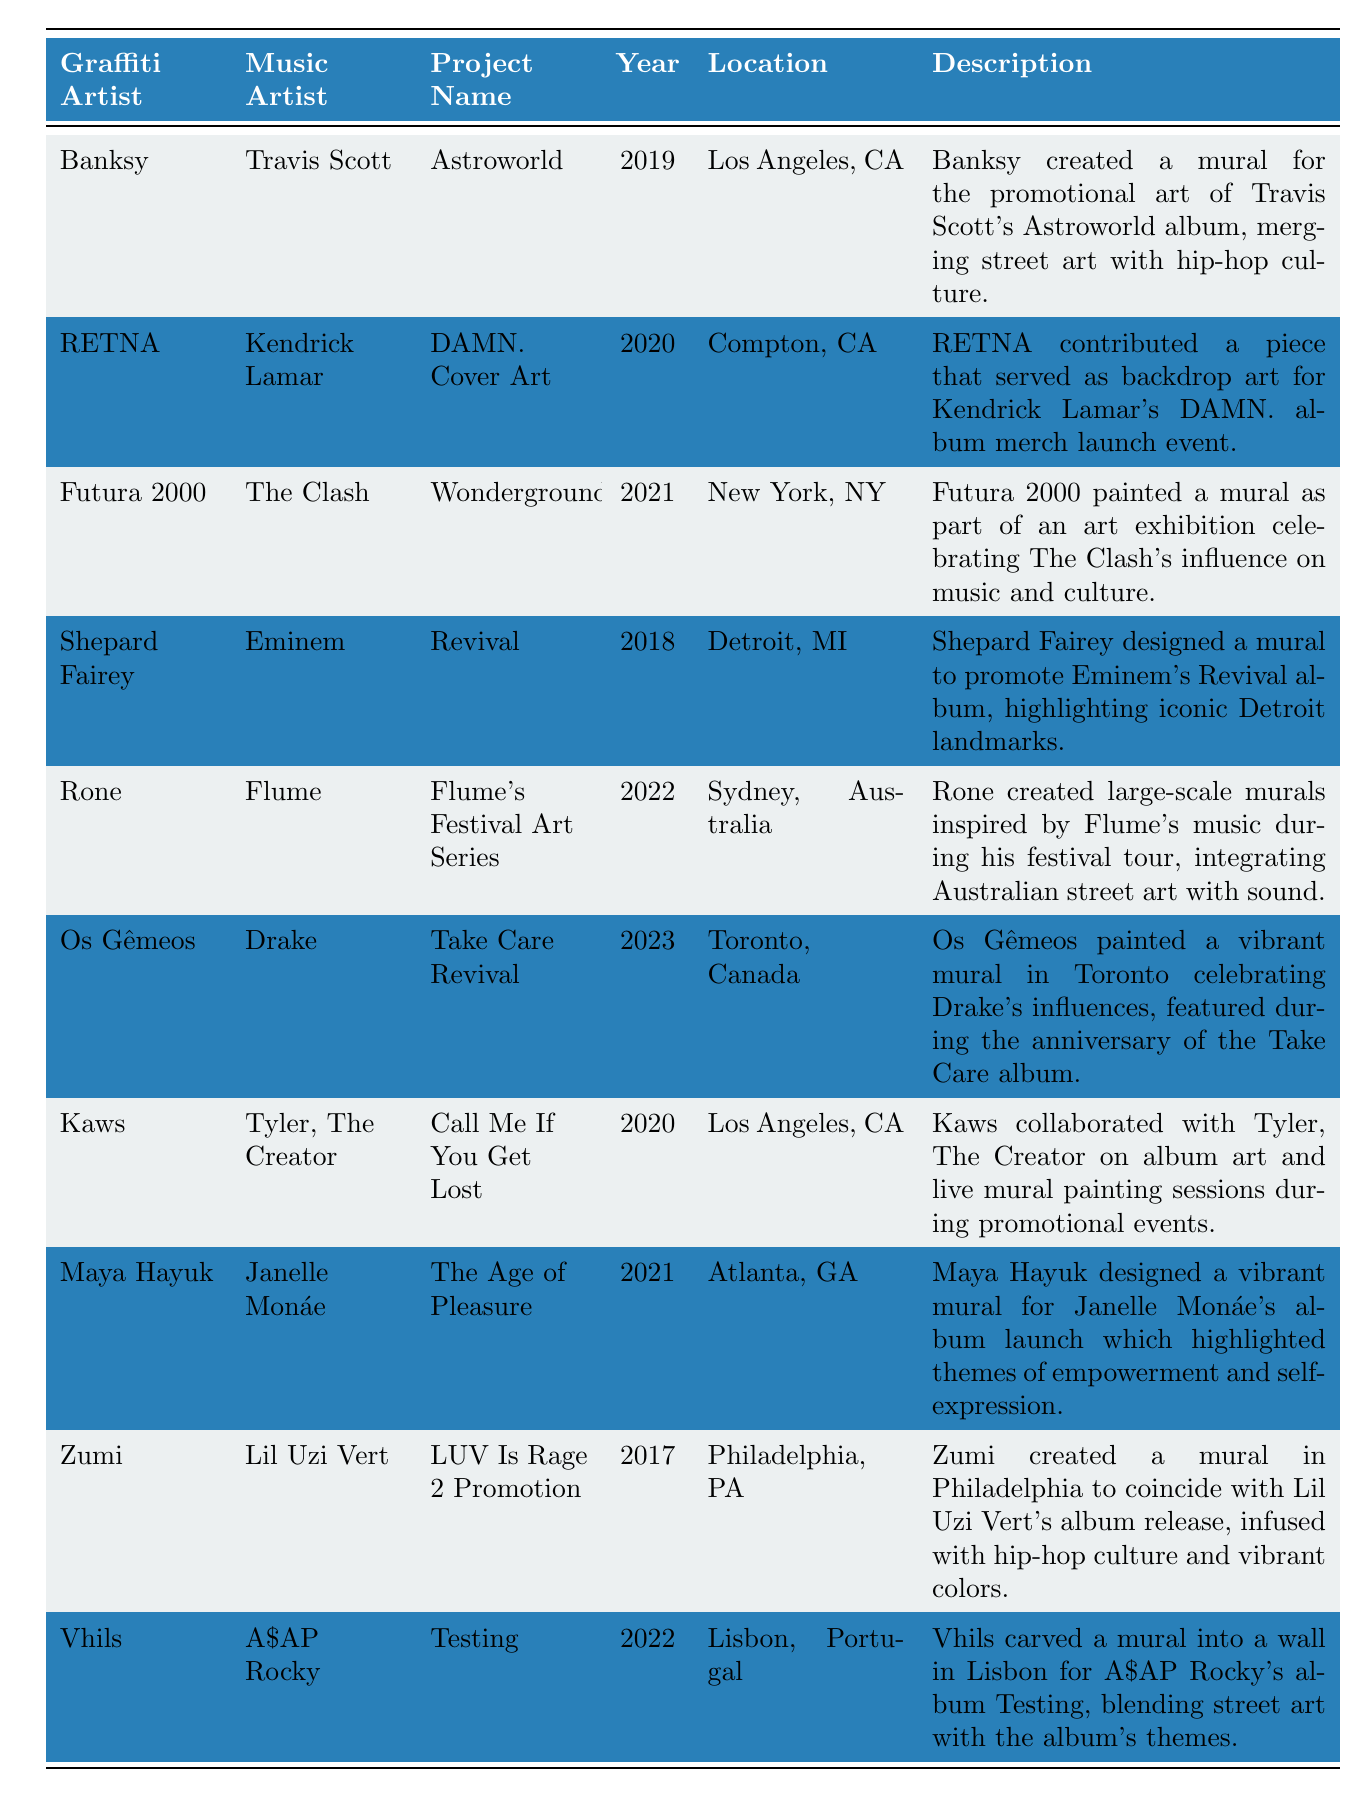What year did Banksy collaborate with Travis Scott? The table shows that Banksy collaborated with Travis Scott in the year 2019.
Answer: 2019 Which music artist collaborated with Shepard Fairey? According to the table, Shepard Fairey collaborated with Eminem.
Answer: Eminem How many graffiti artists collaborated with artists in 2020? The table lists three entries for collaborations in 2020: RETNA with Kendrick Lamar, Kaws with Tyler, The Creator, and Os Gêmeos with Drake. Therefore, the answer is 3.
Answer: 3 Which project name was associated with Lil Uzi Vert? The table specifies that Zumi created a mural for the project "LUV Is Rage 2 Promotion" in conjunction with Lil Uzi Vert.
Answer: LUV Is Rage 2 Promotion What city hosted the collaboration between Rone and Flume? The table indicates that the collaboration between Rone and Flume took place in Sydney, Australia.
Answer: Sydney, Australia Did any artists collaborate in 2018? Yes, the table shows that Shepard Fairey collaborated with Eminem in 2018.
Answer: Yes What is the project name for the collaboration between Os Gêmeos and Drake? From the table, the project name for Os Gêmeos' collaboration with Drake is "Take Care Revival".
Answer: Take Care Revival Who were the graffiti artists involved in murals in Los Angeles? The table lists Banksy and Kaws as the graffiti artists who created murals in Los Angeles.
Answer: Banksy, Kaws What is the newest collaboration listed in the table? The table shows that the latest collaboration is between Os Gêmeos and Drake from 2023.
Answer: Os Gêmeos and Drake Was there a collaboration for a Janelle Monáe project? Yes, Maya Hayuk designed a mural for Janelle Monáe's album launch in 2021.
Answer: Yes How many projects involved the music artist A$AP Rocky? According to the table, there is one project involving A$AP Rocky, which is "Testing" by Vhils.
Answer: 1 Which graffiti artist created a mural for the promotional art of an album? The table indicates that Banksy created a mural for the promotional art of Travis Scott's Astroworld album.
Answer: Banksy Which project's description highlights themes of empowerment? The description for Maya Hayuk's mural for Janelle Monáe's album "The Age of Pleasure" contains themes of empowerment and self-expression.
Answer: The Age of Pleasure How many years apart were the collaborations with Eminem and Kendrick Lamar? Shepard Fairey collaborated with Eminem in 2018 and RETNA collaborated with Kendrick Lamar in 2020. The difference is 2 years.
Answer: 2 years Which music artist's collaborative project was associated with a vibrant mural? The table shows that multiple artists created vibrant murals, specifically mentioning Maya Hayuk for Janelle Monáe and Os Gêmeos for Drake.
Answer: Janelle Monáe, Drake 